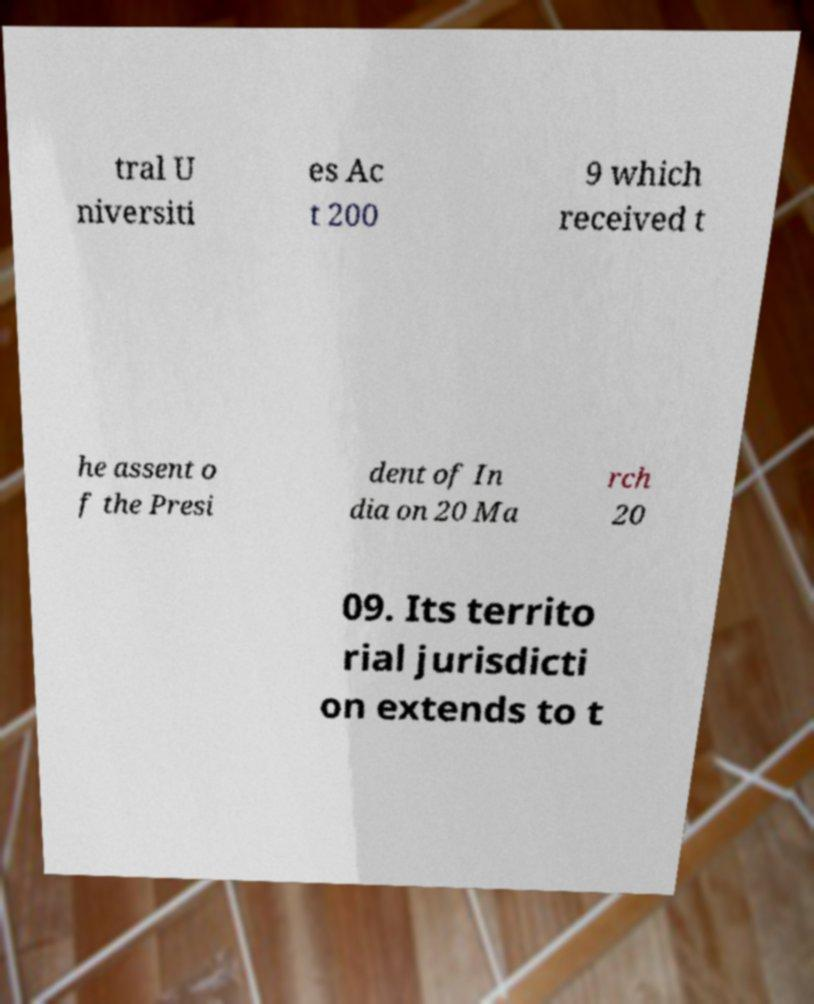Can you read and provide the text displayed in the image?This photo seems to have some interesting text. Can you extract and type it out for me? tral U niversiti es Ac t 200 9 which received t he assent o f the Presi dent of In dia on 20 Ma rch 20 09. Its territo rial jurisdicti on extends to t 